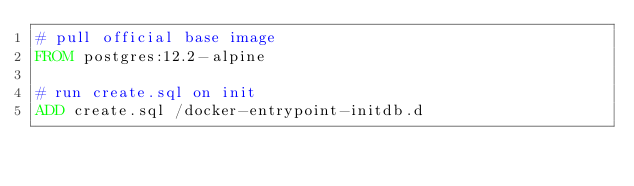<code> <loc_0><loc_0><loc_500><loc_500><_Dockerfile_># pull official base image
FROM postgres:12.2-alpine

# run create.sql on init
ADD create.sql /docker-entrypoint-initdb.d</code> 